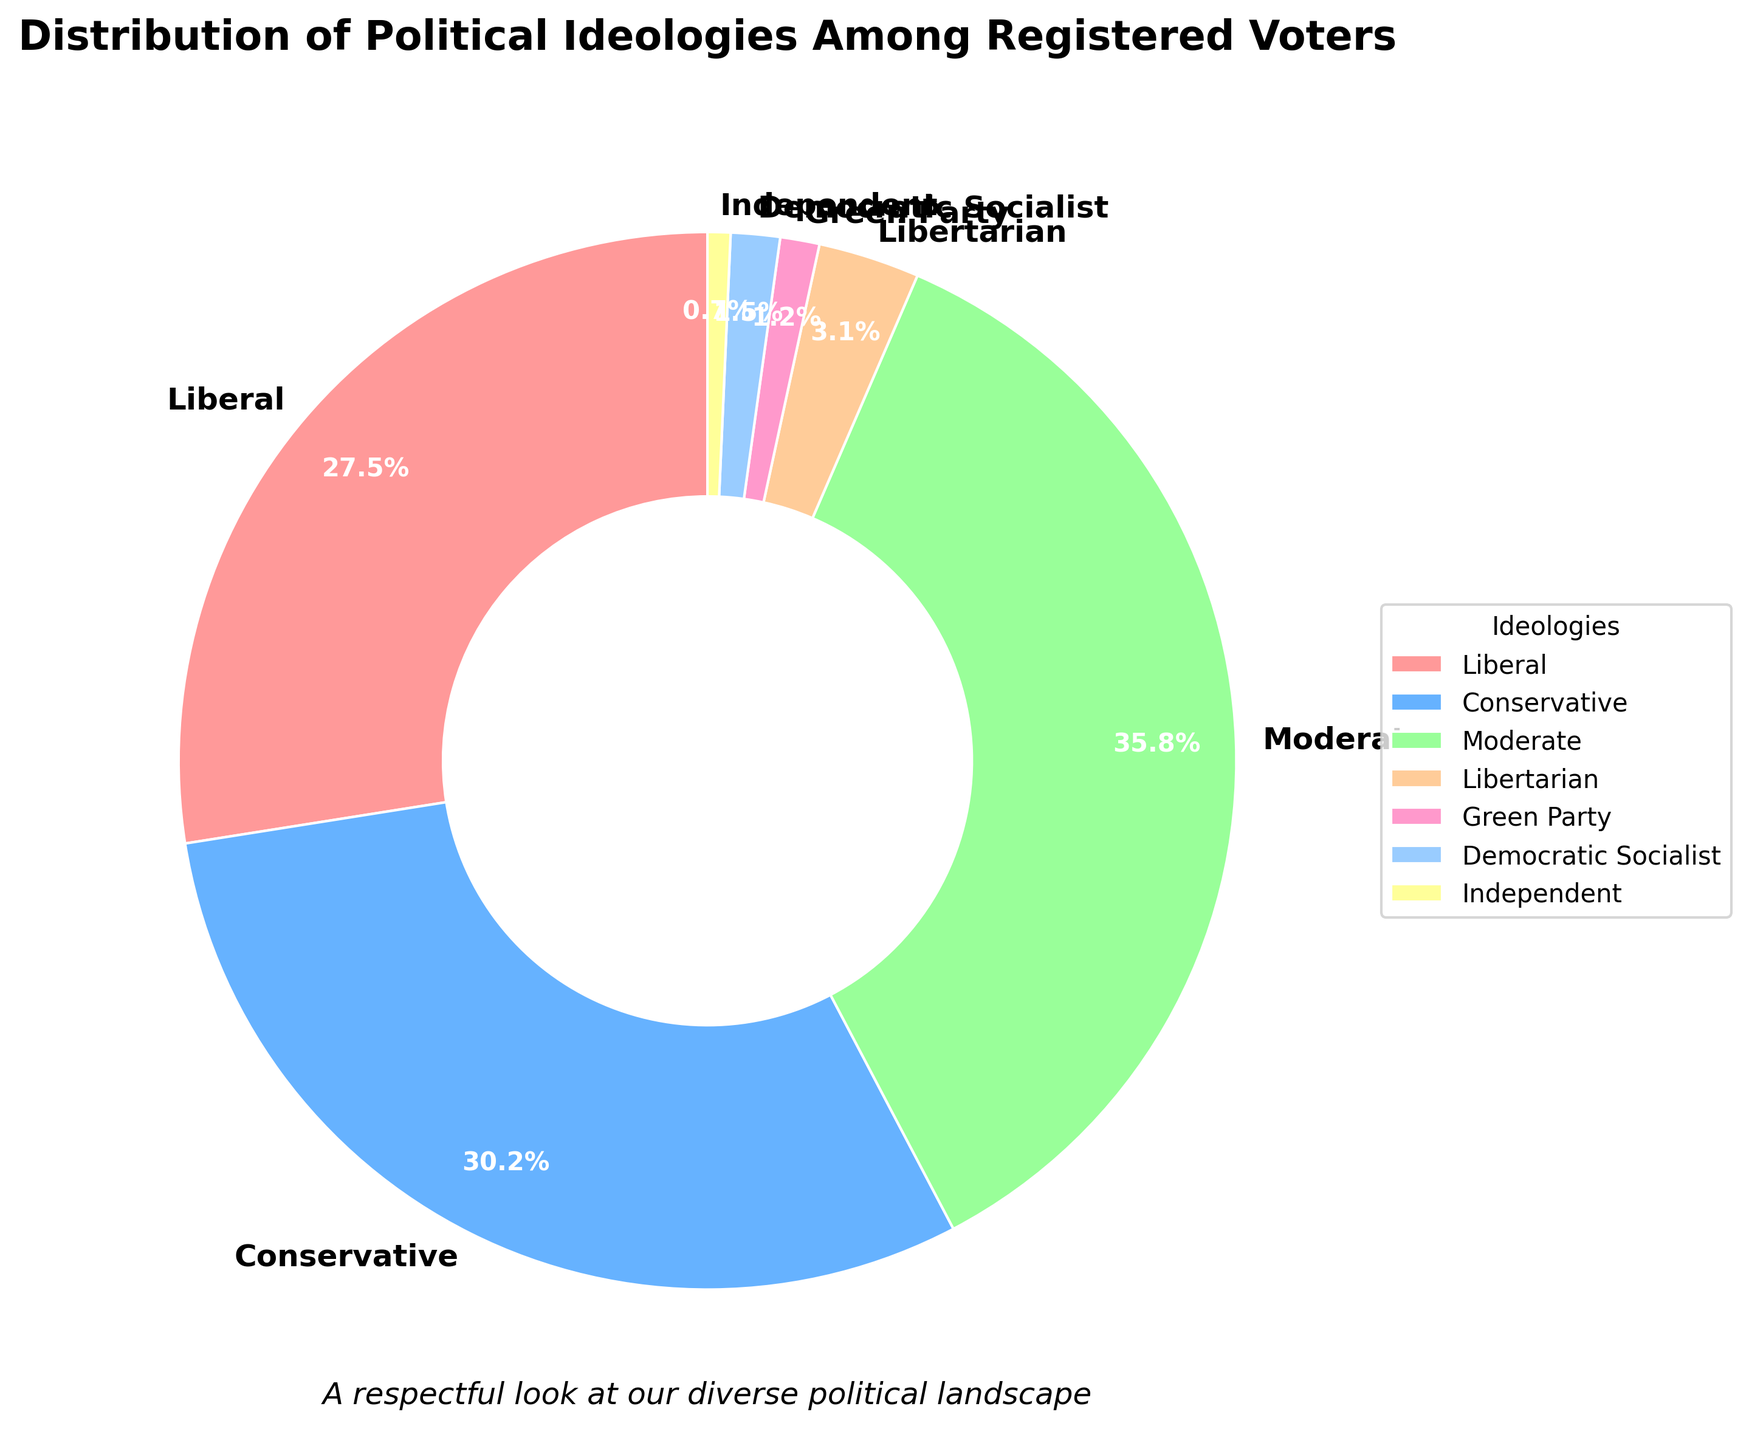What's the most prominent political ideology based on the chart? The chart shows that "Moderate" has the highest percentage at 35.8%, making it the most prominent ideology among registered voters.
Answer: Moderate Which ideology has the smallest representation among registered voters? According to the chart, "Independent" has the smallest percentage at 0.7%, indicating it has the least representation.
Answer: Independent What is the combined percentage of voters identifying as Liberal and Conservative? The chart indicates "Liberal" constitutes 27.5% and "Conservative" 30.2%. Adding these gives 27.5 + 30.2 = 57.7%.
Answer: 57.7% How much larger is the Moderate group compared to the Green Party group? The chart shows "Moderate" at 35.8% and "Green Party" at 1.2%. The difference is 35.8 - 1.2 = 34.6%.
Answer: 34.6% Which color is associated with the "Democratic Socialist" ideology? The chart visually represents "Democratic Socialist" with a distinct color, identified as purple.
Answer: purple Is there any ideology that constitutes less than 1% of the total registered voters? According to the chart, "Independent" is the only ideology that constitutes less than 1% with 0.7%.
Answer: Yes, Independent How do the percentages of Conservative and Liberal compare? The "Conservative" ideology accounts for 30.2%, while "Liberal" accounts for 27.5%. This shows that Conservatives represent a higher percentage by 30.2 - 27.5 = 2.7%.
Answer: Conservative is higher by 2.7% What is the total percentage of registered voters identified as Green Party, Libertarian, and Democratic Socialist? The chart shows "Green Party" at 1.2%, "Libertarian" at 3.1%, and "Democratic Socialist" at 1.5%. Adding these gives 1.2 + 3.1 + 1.5 = 5.8%.
Answer: 5.8% What is the percentage difference between Moderate and Conservative ideologies? The chart lists "Moderate" at 35.8% and "Conservative" at 30.2%. The difference is 35.8 - 30.2 = 5.6%.
Answer: 5.6% 